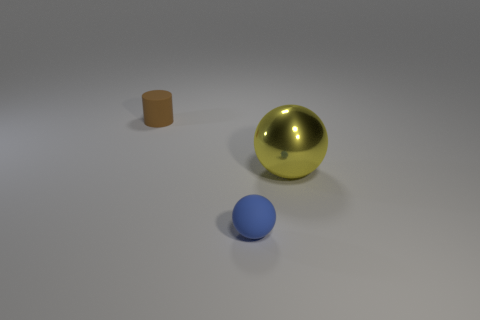There is a blue matte object; is its size the same as the object behind the shiny sphere?
Offer a terse response. Yes. Is the matte ball the same size as the yellow sphere?
Offer a very short reply. No. Are there any matte things that have the same size as the brown rubber cylinder?
Your answer should be compact. Yes. There is a ball that is to the right of the small blue rubber ball; what material is it?
Your answer should be compact. Metal. There is a thing that is made of the same material as the small brown cylinder; what is its color?
Your response must be concise. Blue. How many rubber objects are tiny blue objects or tiny brown objects?
Keep it short and to the point. 2. The blue thing that is the same size as the cylinder is what shape?
Provide a short and direct response. Sphere. What number of objects are either tiny rubber things in front of the cylinder or objects behind the small sphere?
Your answer should be very brief. 3. There is a brown cylinder that is the same size as the blue thing; what material is it?
Your answer should be very brief. Rubber. What number of other objects are there of the same material as the large yellow thing?
Give a very brief answer. 0. 